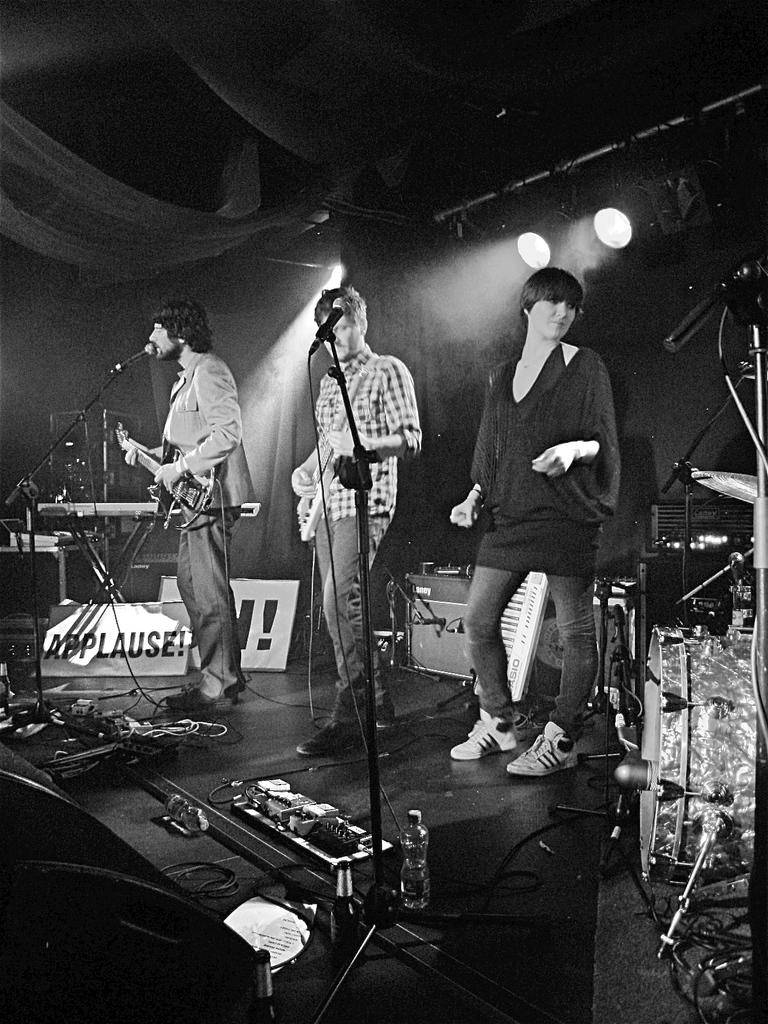How many people are in the image? There are three people in the image. What are the people doing in the image? The people are standing on a dais. What objects are the people holding in the image? One person is holding a guitar, and another person is holding a microphone. What can be seen attached to the ceiling in the image? There are lights attached to the ceiling in the image. What type of theory is being discussed by the people on the hill in the image? There is no hill present in the image, and the people are standing on a dais, not discussing any theories. 